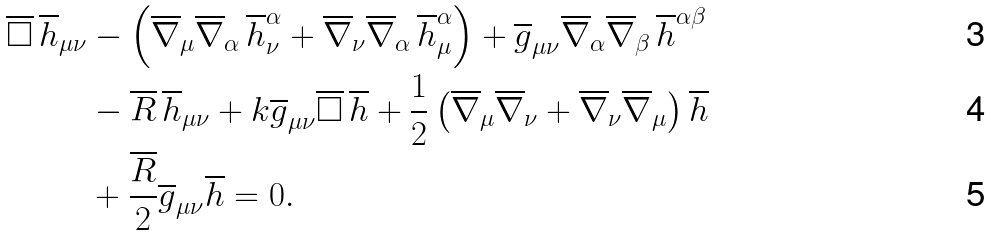<formula> <loc_0><loc_0><loc_500><loc_500>\overline { \square } \, \overline { h } _ { \mu \nu } & - \left ( \overline { \nabla } _ { \mu } \overline { \nabla } _ { \alpha } \, \overline { h } ^ { \alpha } _ { \nu } + \overline { \nabla } _ { \nu } \overline { \nabla } _ { \alpha } \, \overline { h } ^ { \alpha } _ { \mu } \right ) + \overline { g } _ { \mu \nu } \overline { \nabla } _ { \alpha } \overline { \nabla } _ { \beta } \, \overline { h } ^ { \alpha \beta } \\ & - \overline { R } \, \overline { h } _ { \mu \nu } + k \overline { g } _ { \mu \nu } \overline { \square } \, \overline { h } + \frac { 1 } { 2 } \left ( \overline { \nabla } _ { \mu } \overline { \nabla } _ { \nu } + \overline { \nabla } _ { \nu } \overline { \nabla } _ { \mu } \right ) \overline { h } \\ & + \frac { \overline { R } } { 2 } \overline { g } _ { \mu \nu } \overline { h } = 0 .</formula> 